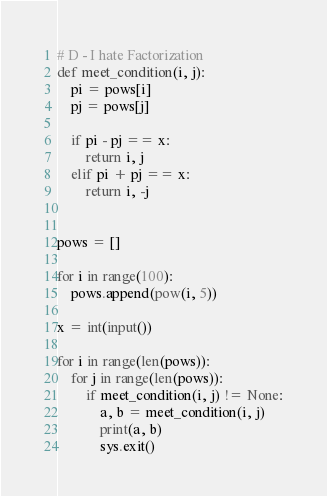<code> <loc_0><loc_0><loc_500><loc_500><_Python_># D - I hate Factorization
def meet_condition(i, j):
	pi = pows[i]
	pj = pows[j]
	
	if pi - pj == x:
		return i, j
	elif pi + pj == x:
		return i, -j


pows = []

for i in range(100):
	pows.append(pow(i, 5))

x = int(input())

for i in range(len(pows)):
	for j in range(len(pows)):
		if meet_condition(i, j) != None:
			a, b = meet_condition(i, j)
			print(a, b)
			sys.exit()</code> 